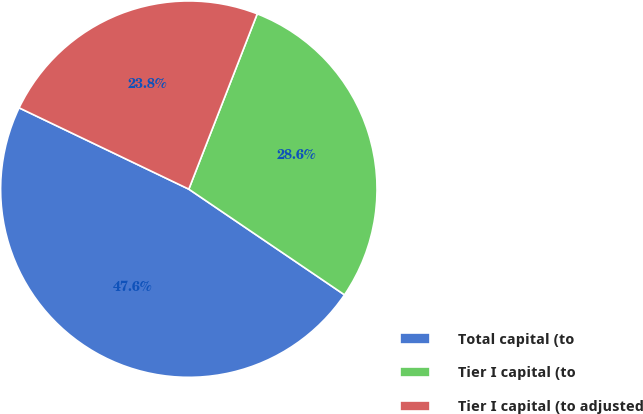<chart> <loc_0><loc_0><loc_500><loc_500><pie_chart><fcel>Total capital (to<fcel>Tier I capital (to<fcel>Tier I capital (to adjusted<nl><fcel>47.62%<fcel>28.57%<fcel>23.81%<nl></chart> 